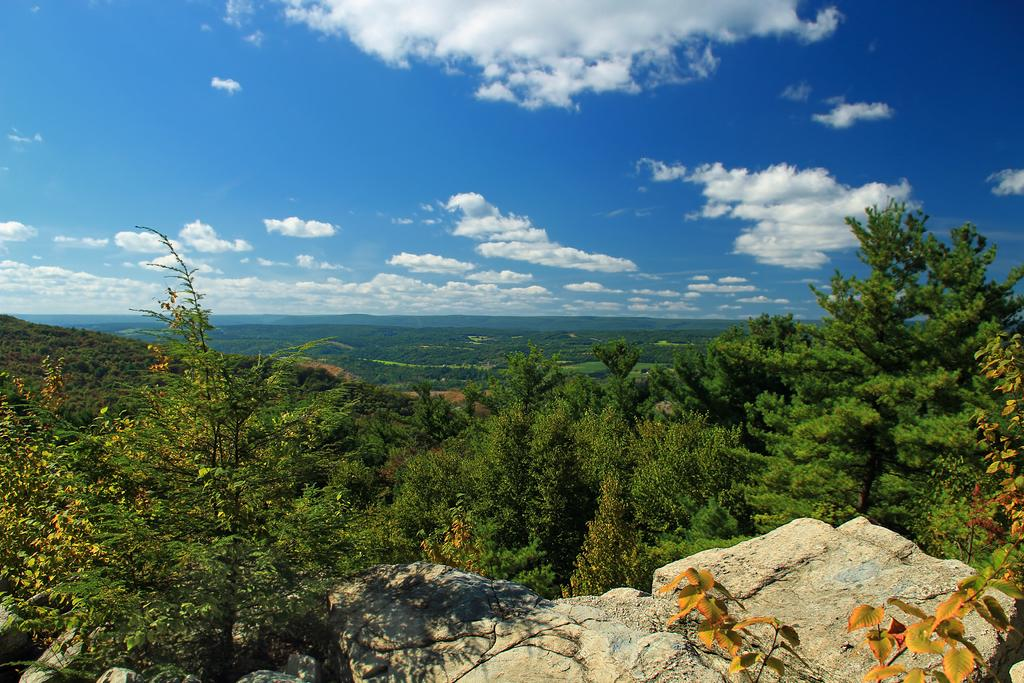What type of object can be seen in the image? There is a stone in the image. What other natural elements are present in the image? There are plants and trees in the image. What can be seen in the background of the image? The sky is visible in the image, and clouds are present in the sky. What type of vegetable is growing on the stone in the image? There are no vegetables present in the image; it features a stone, plants, trees, and a sky with clouds. 